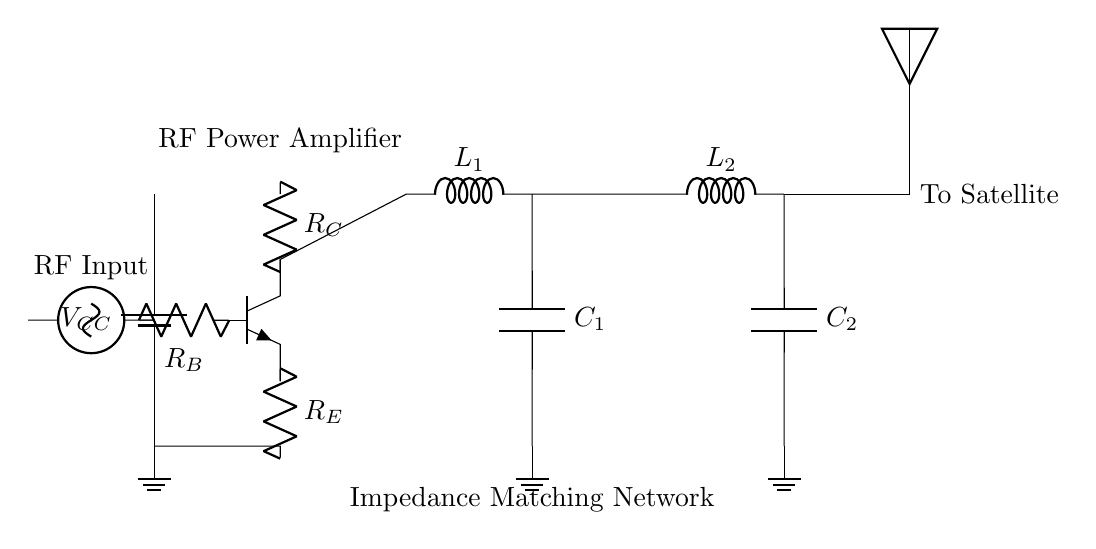What is the type of amplifier shown in the circuit? The circuit diagram represents a radio frequency power amplifier as indicated by the label "RF Power Amplifier" above the transistor symbol.
Answer: RF Power Amplifier What kind of input does the amplifier receive? The circuit includes a connection labeled "RF Input," suggesting that the input signal to the amplifier is a radio frequency signal.
Answer: RF Input How many inductors are in the output matching network? In the diagram, there are two inductors labeled "L1" and "L2" connected in the output stage of the circuit, which confirms there are two inductors.
Answer: 2 What is the purpose of the component labeled "R_C"? The resistor labeled "R_C" provides biasing for the transistor, ensuring it operates in the appropriate region for amplification.
Answer: Biasing How does the output signal connect to the next stage? The output signal is connected to an antenna, as indicated by the symbol at the end of the circuit, suggesting it transmits the amplified signal to a satellite.
Answer: To Satellite What components are used in the impedance matching network? The impedance matching network consists of an inductor "L1," a capacitor "C1," another inductor "L2," and a second capacitor "C2," which work together to match the load impedance.
Answer: L1, C1, L2, C2 What is the ground reference point for the circuit? The circuit provides three ground symbols, indicating that these points are at zero volts and serve as the reference for the entire circuit.
Answer: Ground 